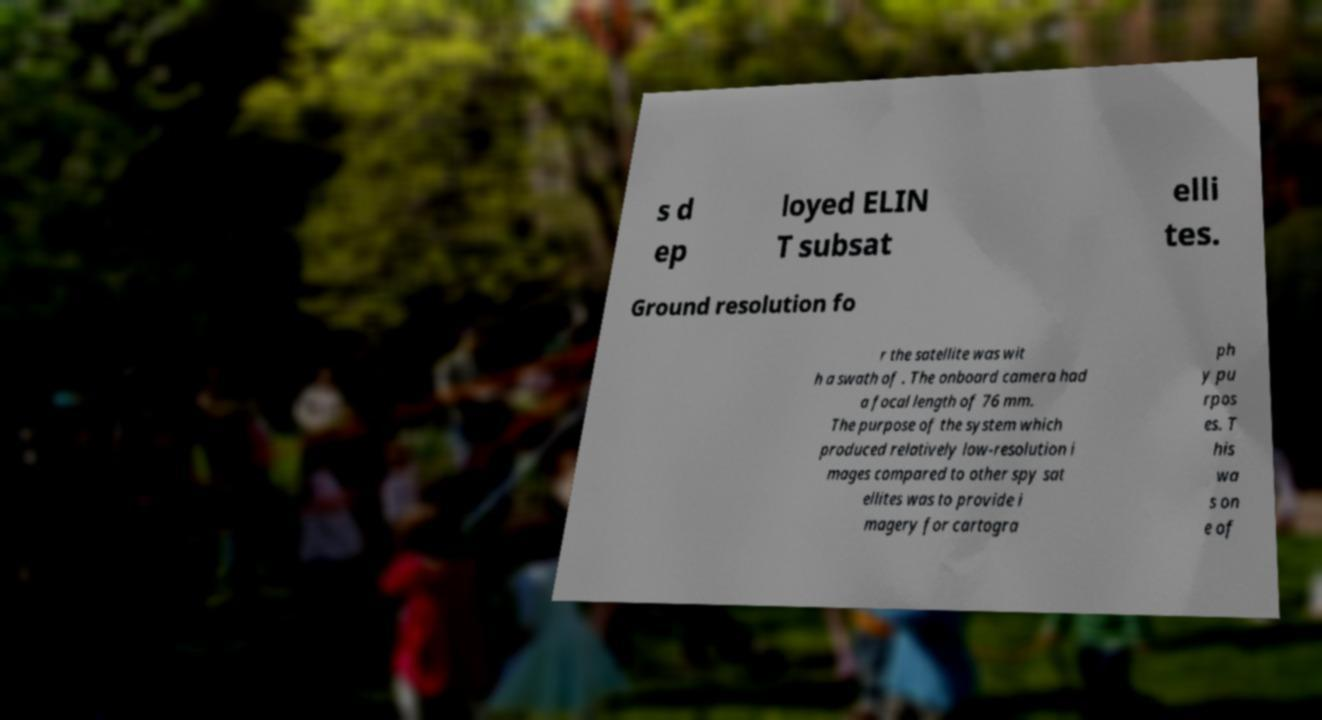Could you extract and type out the text from this image? s d ep loyed ELIN T subsat elli tes. Ground resolution fo r the satellite was wit h a swath of . The onboard camera had a focal length of 76 mm. The purpose of the system which produced relatively low-resolution i mages compared to other spy sat ellites was to provide i magery for cartogra ph y pu rpos es. T his wa s on e of 